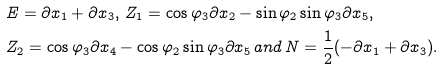Convert formula to latex. <formula><loc_0><loc_0><loc_500><loc_500>& E = \partial x _ { 1 } + \partial x _ { 3 } , \, Z _ { 1 } = \cos \varphi _ { 3 } \partial x _ { 2 } - \sin \varphi _ { 2 } \sin \varphi _ { 3 } \partial x _ { 5 } , \\ & Z _ { 2 } = \cos \varphi _ { 3 } \partial x _ { 4 } - \cos \varphi _ { 2 } \sin \varphi _ { 3 } \partial x _ { 5 } \, a n d \, N = \frac { 1 } { 2 } ( - \partial x _ { 1 } + \partial x _ { 3 } ) .</formula> 